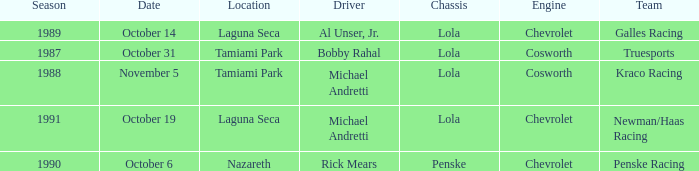Would you mind parsing the complete table? {'header': ['Season', 'Date', 'Location', 'Driver', 'Chassis', 'Engine', 'Team'], 'rows': [['1989', 'October 14', 'Laguna Seca', 'Al Unser, Jr.', 'Lola', 'Chevrolet', 'Galles Racing'], ['1987', 'October 31', 'Tamiami Park', 'Bobby Rahal', 'Lola', 'Cosworth', 'Truesports'], ['1988', 'November 5', 'Tamiami Park', 'Michael Andretti', 'Lola', 'Cosworth', 'Kraco Racing'], ['1991', 'October 19', 'Laguna Seca', 'Michael Andretti', 'Lola', 'Chevrolet', 'Newman/Haas Racing'], ['1990', 'October 6', 'Nazareth', 'Rick Mears', 'Penske', 'Chevrolet', 'Penske Racing']]} Which team raced on October 19? Newman/Haas Racing. 